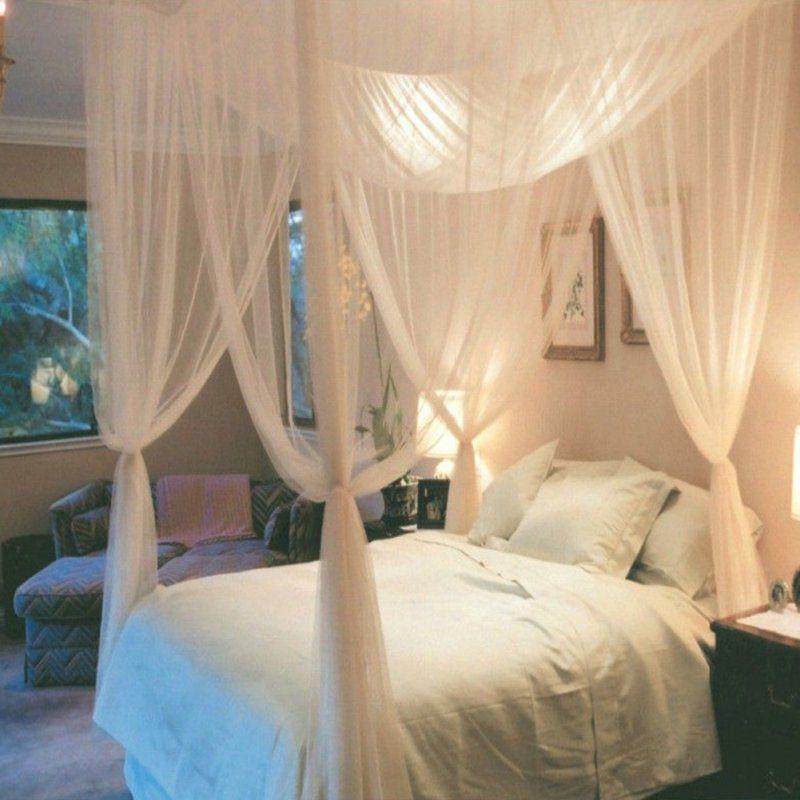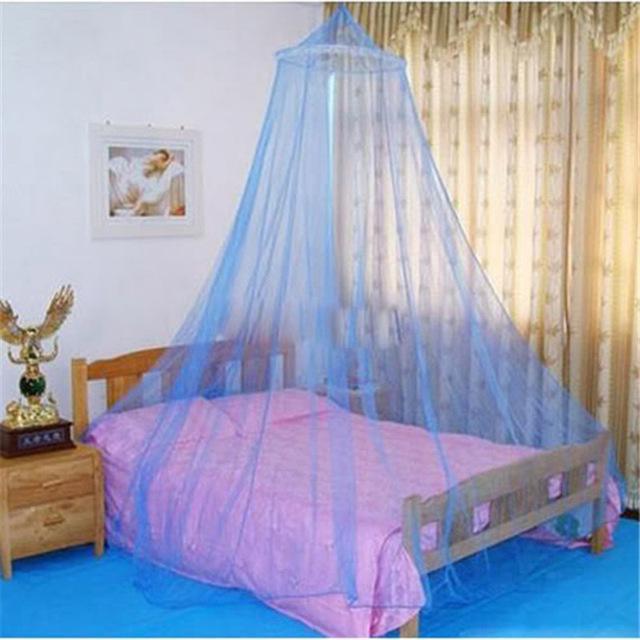The first image is the image on the left, the second image is the image on the right. Analyze the images presented: Is the assertion "The left and right image contains the same number of canopies one square and one circle." valid? Answer yes or no. Yes. 